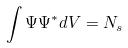<formula> <loc_0><loc_0><loc_500><loc_500>\int \Psi \Psi ^ { * } d V = N _ { s }</formula> 